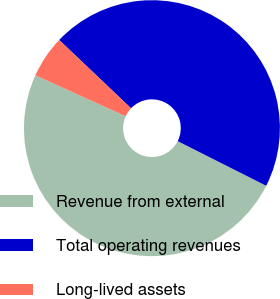Convert chart to OTSL. <chart><loc_0><loc_0><loc_500><loc_500><pie_chart><fcel>Revenue from external<fcel>Total operating revenues<fcel>Long-lived assets<nl><fcel>49.35%<fcel>45.33%<fcel>5.32%<nl></chart> 